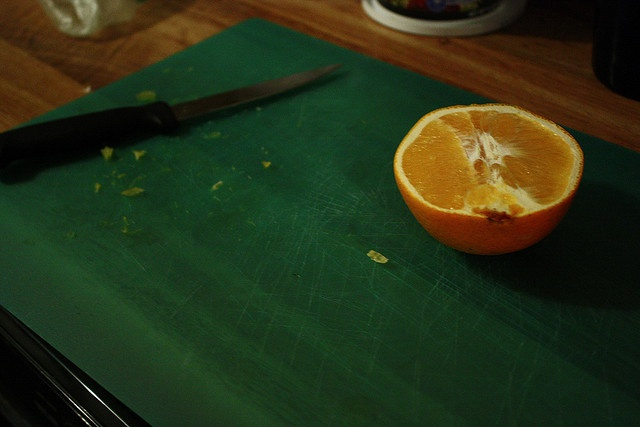Describe the objects in this image and their specific colors. I can see dining table in black, darkgreen, maroon, and olive tones, orange in maroon, olive, and tan tones, and knife in maroon, black, and darkgreen tones in this image. 